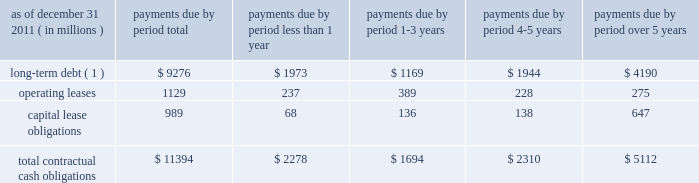We maintain an effective universal shelf registration that allows for the public offering and sale of debt securities , capital securities , common stock , depositary shares and preferred stock , and warrants to purchase such securities , including any shares into which the preferred stock and depositary shares may be convertible , or any combination thereof .
We have , as discussed previously , issued in the past , and we may issue in the future , securities pursuant to the shelf registration .
The issuance of debt or equity securities will depend on future market conditions , funding needs and other factors .
Additional information about debt and equity securities issued pursuant to this shelf registration is provided in notes 9 and 12 to the consolidated financial statements included under item 8 .
We currently maintain a corporate commercial paper program , under which we can issue up to $ 3 billion with original maturities of up to 270 days from the date of issue .
At december 31 , 2011 , we had $ 2.38 billion of commercial paper outstanding , compared to $ 2.80 billion at december 31 , 2010 .
Additional information about our corporate commercial paper program is provided in note 8 to the consolidated financial statements included under item 8 .
State street bank had initial board authority to issue bank notes up to an aggregate of $ 5 billion , including up to $ 1 billion of subordinated bank notes .
Approximately $ 2.05 billion was available under this board authority as of december 31 , 2011 .
In 2011 , $ 2.45 billion of senior notes , which were outstanding at december 31 , 2010 , matured .
State street bank currently maintains a line of credit with a financial institution of cad $ 800 million , or approximately $ 787 million as of december 31 , 2011 , to support its canadian securities processing operations .
The line of credit has no stated termination date and is cancelable by either party with prior notice .
As of december 31 , 2011 , no balance was outstanding on this line of credit .
Contractual cash obligations .
( 1 ) long-term debt excludes capital lease obligations ( presented as a separate line item ) and the effect of interest-rate swaps .
Interest payments were calculated at the stated rate with the exception of floating-rate debt , for which payments were calculated using the indexed rate in effect as of december 31 , 2011 .
The obligations presented in the table above are recorded in our consolidated statement of condition at december 31 , 2011 , except for interest on long-term debt and capital lease obligations .
The table does not include obligations which will be settled in cash , primarily in less than one year , such as deposits , federal funds purchased , securities sold under repurchase agreements and other short-term borrowings .
Additional information about deposits , federal funds purchased , securities sold under repurchase agreements and other short-term borrowings is provided in notes 7 and 8 to the consolidated financial statements included under item 8 .
The table does not include obligations related to derivative instruments , because the amounts included in our consolidated statement of condition at december 31 , 2011 related to derivatives do not represent the amounts that may ultimately be paid under the contracts upon settlement .
Additional information about derivative contracts is provided in note 16 to the consolidated financial statements included under item 8 .
We have obligations under pension and other post-retirement benefit plans , more fully described in note 18 to the consolidated financial statements included under item 8 , which are not included in the above table .
Additional information about contractual cash obligations related to long-term debt and operating and capital leases is provided in notes 9 and 19 to the consolidated financial statements included under item 8 .
The consolidated statement of cash flows , also included under item 8 , provides additional liquidity information. .
In 2011 what was the percent of the total contractual obligations for long-term debt that was due in less than 1 year? 
Computations: (1973 / 9276)
Answer: 0.2127. We maintain an effective universal shelf registration that allows for the public offering and sale of debt securities , capital securities , common stock , depositary shares and preferred stock , and warrants to purchase such securities , including any shares into which the preferred stock and depositary shares may be convertible , or any combination thereof .
We have , as discussed previously , issued in the past , and we may issue in the future , securities pursuant to the shelf registration .
The issuance of debt or equity securities will depend on future market conditions , funding needs and other factors .
Additional information about debt and equity securities issued pursuant to this shelf registration is provided in notes 9 and 12 to the consolidated financial statements included under item 8 .
We currently maintain a corporate commercial paper program , under which we can issue up to $ 3 billion with original maturities of up to 270 days from the date of issue .
At december 31 , 2011 , we had $ 2.38 billion of commercial paper outstanding , compared to $ 2.80 billion at december 31 , 2010 .
Additional information about our corporate commercial paper program is provided in note 8 to the consolidated financial statements included under item 8 .
State street bank had initial board authority to issue bank notes up to an aggregate of $ 5 billion , including up to $ 1 billion of subordinated bank notes .
Approximately $ 2.05 billion was available under this board authority as of december 31 , 2011 .
In 2011 , $ 2.45 billion of senior notes , which were outstanding at december 31 , 2010 , matured .
State street bank currently maintains a line of credit with a financial institution of cad $ 800 million , or approximately $ 787 million as of december 31 , 2011 , to support its canadian securities processing operations .
The line of credit has no stated termination date and is cancelable by either party with prior notice .
As of december 31 , 2011 , no balance was outstanding on this line of credit .
Contractual cash obligations .
( 1 ) long-term debt excludes capital lease obligations ( presented as a separate line item ) and the effect of interest-rate swaps .
Interest payments were calculated at the stated rate with the exception of floating-rate debt , for which payments were calculated using the indexed rate in effect as of december 31 , 2011 .
The obligations presented in the table above are recorded in our consolidated statement of condition at december 31 , 2011 , except for interest on long-term debt and capital lease obligations .
The table does not include obligations which will be settled in cash , primarily in less than one year , such as deposits , federal funds purchased , securities sold under repurchase agreements and other short-term borrowings .
Additional information about deposits , federal funds purchased , securities sold under repurchase agreements and other short-term borrowings is provided in notes 7 and 8 to the consolidated financial statements included under item 8 .
The table does not include obligations related to derivative instruments , because the amounts included in our consolidated statement of condition at december 31 , 2011 related to derivatives do not represent the amounts that may ultimately be paid under the contracts upon settlement .
Additional information about derivative contracts is provided in note 16 to the consolidated financial statements included under item 8 .
We have obligations under pension and other post-retirement benefit plans , more fully described in note 18 to the consolidated financial statements included under item 8 , which are not included in the above table .
Additional information about contractual cash obligations related to long-term debt and operating and capital leases is provided in notes 9 and 19 to the consolidated financial statements included under item 8 .
The consolidated statement of cash flows , also included under item 8 , provides additional liquidity information. .
What was the percent change in the value of commercial paper outstanding between 2010 and 2011? 
Computations: ((2.80 - 2.38) / 2.38)
Answer: 0.17647. 